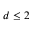<formula> <loc_0><loc_0><loc_500><loc_500>d \leq 2</formula> 